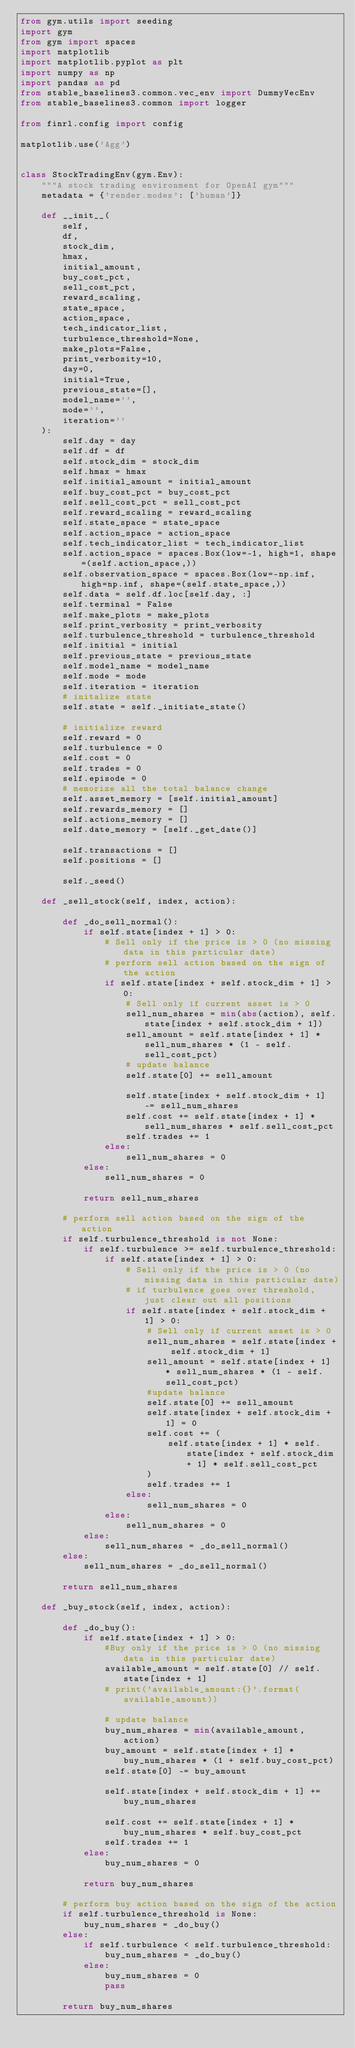<code> <loc_0><loc_0><loc_500><loc_500><_Python_>from gym.utils import seeding
import gym
from gym import spaces
import matplotlib
import matplotlib.pyplot as plt
import numpy as np
import pandas as pd
from stable_baselines3.common.vec_env import DummyVecEnv
from stable_baselines3.common import logger

from finrl.config import config

matplotlib.use('Agg')


class StockTradingEnv(gym.Env):
    """A stock trading environment for OpenAI gym"""
    metadata = {'render.modes': ['human']}

    def __init__(
        self,
        df,
        stock_dim,
        hmax,
        initial_amount,
        buy_cost_pct,
        sell_cost_pct,
        reward_scaling,
        state_space,
        action_space,
        tech_indicator_list,
        turbulence_threshold=None,
        make_plots=False,
        print_verbosity=10,
        day=0,
        initial=True,
        previous_state=[],
        model_name='',
        mode='',
        iteration=''
    ):
        self.day = day
        self.df = df
        self.stock_dim = stock_dim
        self.hmax = hmax
        self.initial_amount = initial_amount
        self.buy_cost_pct = buy_cost_pct
        self.sell_cost_pct = sell_cost_pct
        self.reward_scaling = reward_scaling
        self.state_space = state_space
        self.action_space = action_space
        self.tech_indicator_list = tech_indicator_list
        self.action_space = spaces.Box(low=-1, high=1, shape=(self.action_space,))
        self.observation_space = spaces.Box(low=-np.inf, high=np.inf, shape=(self.state_space,))
        self.data = self.df.loc[self.day, :]
        self.terminal = False
        self.make_plots = make_plots
        self.print_verbosity = print_verbosity
        self.turbulence_threshold = turbulence_threshold
        self.initial = initial
        self.previous_state = previous_state
        self.model_name = model_name
        self.mode = mode
        self.iteration = iteration
        # initalize state
        self.state = self._initiate_state()

        # initialize reward
        self.reward = 0
        self.turbulence = 0
        self.cost = 0
        self.trades = 0
        self.episode = 0
        # memorize all the total balance change
        self.asset_memory = [self.initial_amount]
        self.rewards_memory = []
        self.actions_memory = []
        self.date_memory = [self._get_date()]

        self.transactions = []
        self.positions = []

        self._seed()

    def _sell_stock(self, index, action):

        def _do_sell_normal():
            if self.state[index + 1] > 0:
                # Sell only if the price is > 0 (no missing data in this particular date)
                # perform sell action based on the sign of the action
                if self.state[index + self.stock_dim + 1] > 0:
                    # Sell only if current asset is > 0
                    sell_num_shares = min(abs(action), self.state[index + self.stock_dim + 1])
                    sell_amount = self.state[index + 1] * sell_num_shares * (1 - self.sell_cost_pct)
                    # update balance
                    self.state[0] += sell_amount

                    self.state[index + self.stock_dim + 1] -= sell_num_shares
                    self.cost += self.state[index + 1] * sell_num_shares * self.sell_cost_pct
                    self.trades += 1
                else:
                    sell_num_shares = 0
            else:
                sell_num_shares = 0

            return sell_num_shares

        # perform sell action based on the sign of the action
        if self.turbulence_threshold is not None:
            if self.turbulence >= self.turbulence_threshold:
                if self.state[index + 1] > 0:
                    # Sell only if the price is > 0 (no missing data in this particular date)
                    # if turbulence goes over threshold, just clear out all positions
                    if self.state[index + self.stock_dim + 1] > 0:
                        # Sell only if current asset is > 0
                        sell_num_shares = self.state[index + self.stock_dim + 1]
                        sell_amount = self.state[index + 1] * sell_num_shares * (1 - self.sell_cost_pct)
                        #update balance
                        self.state[0] += sell_amount
                        self.state[index + self.stock_dim + 1] = 0
                        self.cost += (
                            self.state[index + 1] * self.state[index + self.stock_dim + 1] * self.sell_cost_pct
                        )
                        self.trades += 1
                    else:
                        sell_num_shares = 0
                else:
                    sell_num_shares = 0
            else:
                sell_num_shares = _do_sell_normal()
        else:
            sell_num_shares = _do_sell_normal()

        return sell_num_shares

    def _buy_stock(self, index, action):

        def _do_buy():
            if self.state[index + 1] > 0:
                #Buy only if the price is > 0 (no missing data in this particular date)
                available_amount = self.state[0] // self.state[index + 1]
                # print('available_amount:{}'.format(available_amount))

                # update balance
                buy_num_shares = min(available_amount, action)
                buy_amount = self.state[index + 1] * buy_num_shares * (1 + self.buy_cost_pct)
                self.state[0] -= buy_amount

                self.state[index + self.stock_dim + 1] += buy_num_shares

                self.cost += self.state[index + 1] * buy_num_shares * self.buy_cost_pct
                self.trades += 1
            else:
                buy_num_shares = 0

            return buy_num_shares

        # perform buy action based on the sign of the action
        if self.turbulence_threshold is None:
            buy_num_shares = _do_buy()
        else:
            if self.turbulence < self.turbulence_threshold:
                buy_num_shares = _do_buy()
            else:
                buy_num_shares = 0
                pass

        return buy_num_shares
</code> 